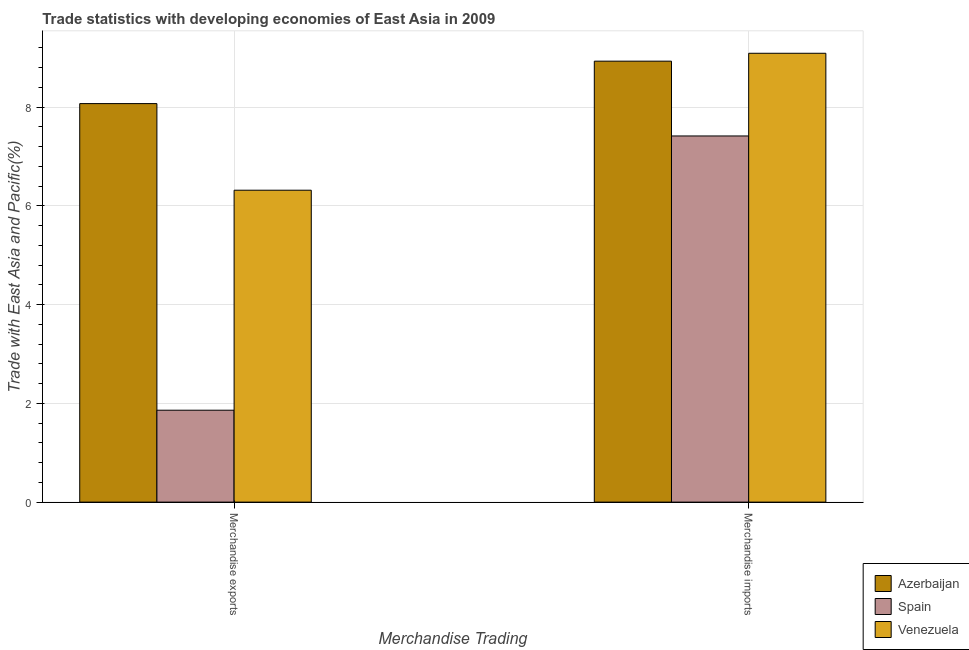What is the label of the 2nd group of bars from the left?
Provide a succinct answer. Merchandise imports. What is the merchandise imports in Spain?
Ensure brevity in your answer.  7.41. Across all countries, what is the maximum merchandise exports?
Offer a very short reply. 8.07. Across all countries, what is the minimum merchandise exports?
Provide a short and direct response. 1.86. In which country was the merchandise imports maximum?
Ensure brevity in your answer.  Venezuela. What is the total merchandise exports in the graph?
Offer a very short reply. 16.25. What is the difference between the merchandise imports in Venezuela and that in Azerbaijan?
Make the answer very short. 0.16. What is the difference between the merchandise exports in Venezuela and the merchandise imports in Spain?
Make the answer very short. -1.1. What is the average merchandise exports per country?
Keep it short and to the point. 5.42. What is the difference between the merchandise imports and merchandise exports in Azerbaijan?
Your answer should be very brief. 0.86. In how many countries, is the merchandise exports greater than 3.2 %?
Your answer should be very brief. 2. What is the ratio of the merchandise imports in Venezuela to that in Azerbaijan?
Give a very brief answer. 1.02. Is the merchandise imports in Azerbaijan less than that in Spain?
Make the answer very short. No. In how many countries, is the merchandise imports greater than the average merchandise imports taken over all countries?
Give a very brief answer. 2. What does the 3rd bar from the right in Merchandise imports represents?
Provide a short and direct response. Azerbaijan. Are all the bars in the graph horizontal?
Your answer should be compact. No. What is the difference between two consecutive major ticks on the Y-axis?
Provide a short and direct response. 2. Does the graph contain any zero values?
Your answer should be compact. No. How many legend labels are there?
Your response must be concise. 3. What is the title of the graph?
Keep it short and to the point. Trade statistics with developing economies of East Asia in 2009. Does "Canada" appear as one of the legend labels in the graph?
Make the answer very short. No. What is the label or title of the X-axis?
Make the answer very short. Merchandise Trading. What is the label or title of the Y-axis?
Offer a very short reply. Trade with East Asia and Pacific(%). What is the Trade with East Asia and Pacific(%) of Azerbaijan in Merchandise exports?
Your answer should be very brief. 8.07. What is the Trade with East Asia and Pacific(%) in Spain in Merchandise exports?
Offer a terse response. 1.86. What is the Trade with East Asia and Pacific(%) of Venezuela in Merchandise exports?
Your answer should be very brief. 6.32. What is the Trade with East Asia and Pacific(%) of Azerbaijan in Merchandise imports?
Give a very brief answer. 8.93. What is the Trade with East Asia and Pacific(%) of Spain in Merchandise imports?
Offer a terse response. 7.41. What is the Trade with East Asia and Pacific(%) of Venezuela in Merchandise imports?
Ensure brevity in your answer.  9.09. Across all Merchandise Trading, what is the maximum Trade with East Asia and Pacific(%) of Azerbaijan?
Offer a very short reply. 8.93. Across all Merchandise Trading, what is the maximum Trade with East Asia and Pacific(%) of Spain?
Your response must be concise. 7.41. Across all Merchandise Trading, what is the maximum Trade with East Asia and Pacific(%) of Venezuela?
Provide a short and direct response. 9.09. Across all Merchandise Trading, what is the minimum Trade with East Asia and Pacific(%) in Azerbaijan?
Ensure brevity in your answer.  8.07. Across all Merchandise Trading, what is the minimum Trade with East Asia and Pacific(%) in Spain?
Ensure brevity in your answer.  1.86. Across all Merchandise Trading, what is the minimum Trade with East Asia and Pacific(%) in Venezuela?
Your answer should be very brief. 6.32. What is the total Trade with East Asia and Pacific(%) in Azerbaijan in the graph?
Make the answer very short. 17. What is the total Trade with East Asia and Pacific(%) in Spain in the graph?
Provide a short and direct response. 9.28. What is the total Trade with East Asia and Pacific(%) in Venezuela in the graph?
Provide a succinct answer. 15.41. What is the difference between the Trade with East Asia and Pacific(%) of Azerbaijan in Merchandise exports and that in Merchandise imports?
Offer a terse response. -0.86. What is the difference between the Trade with East Asia and Pacific(%) in Spain in Merchandise exports and that in Merchandise imports?
Your answer should be compact. -5.55. What is the difference between the Trade with East Asia and Pacific(%) in Venezuela in Merchandise exports and that in Merchandise imports?
Make the answer very short. -2.77. What is the difference between the Trade with East Asia and Pacific(%) of Azerbaijan in Merchandise exports and the Trade with East Asia and Pacific(%) of Spain in Merchandise imports?
Provide a short and direct response. 0.66. What is the difference between the Trade with East Asia and Pacific(%) of Azerbaijan in Merchandise exports and the Trade with East Asia and Pacific(%) of Venezuela in Merchandise imports?
Ensure brevity in your answer.  -1.02. What is the difference between the Trade with East Asia and Pacific(%) in Spain in Merchandise exports and the Trade with East Asia and Pacific(%) in Venezuela in Merchandise imports?
Your answer should be very brief. -7.23. What is the average Trade with East Asia and Pacific(%) of Azerbaijan per Merchandise Trading?
Offer a very short reply. 8.5. What is the average Trade with East Asia and Pacific(%) in Spain per Merchandise Trading?
Give a very brief answer. 4.64. What is the average Trade with East Asia and Pacific(%) of Venezuela per Merchandise Trading?
Provide a short and direct response. 7.7. What is the difference between the Trade with East Asia and Pacific(%) of Azerbaijan and Trade with East Asia and Pacific(%) of Spain in Merchandise exports?
Ensure brevity in your answer.  6.21. What is the difference between the Trade with East Asia and Pacific(%) of Azerbaijan and Trade with East Asia and Pacific(%) of Venezuela in Merchandise exports?
Ensure brevity in your answer.  1.75. What is the difference between the Trade with East Asia and Pacific(%) in Spain and Trade with East Asia and Pacific(%) in Venezuela in Merchandise exports?
Your answer should be very brief. -4.46. What is the difference between the Trade with East Asia and Pacific(%) in Azerbaijan and Trade with East Asia and Pacific(%) in Spain in Merchandise imports?
Make the answer very short. 1.51. What is the difference between the Trade with East Asia and Pacific(%) of Azerbaijan and Trade with East Asia and Pacific(%) of Venezuela in Merchandise imports?
Provide a succinct answer. -0.16. What is the difference between the Trade with East Asia and Pacific(%) in Spain and Trade with East Asia and Pacific(%) in Venezuela in Merchandise imports?
Make the answer very short. -1.67. What is the ratio of the Trade with East Asia and Pacific(%) of Azerbaijan in Merchandise exports to that in Merchandise imports?
Provide a succinct answer. 0.9. What is the ratio of the Trade with East Asia and Pacific(%) in Spain in Merchandise exports to that in Merchandise imports?
Offer a very short reply. 0.25. What is the ratio of the Trade with East Asia and Pacific(%) in Venezuela in Merchandise exports to that in Merchandise imports?
Give a very brief answer. 0.69. What is the difference between the highest and the second highest Trade with East Asia and Pacific(%) in Azerbaijan?
Give a very brief answer. 0.86. What is the difference between the highest and the second highest Trade with East Asia and Pacific(%) of Spain?
Ensure brevity in your answer.  5.55. What is the difference between the highest and the second highest Trade with East Asia and Pacific(%) in Venezuela?
Keep it short and to the point. 2.77. What is the difference between the highest and the lowest Trade with East Asia and Pacific(%) of Azerbaijan?
Provide a short and direct response. 0.86. What is the difference between the highest and the lowest Trade with East Asia and Pacific(%) in Spain?
Ensure brevity in your answer.  5.55. What is the difference between the highest and the lowest Trade with East Asia and Pacific(%) in Venezuela?
Provide a short and direct response. 2.77. 